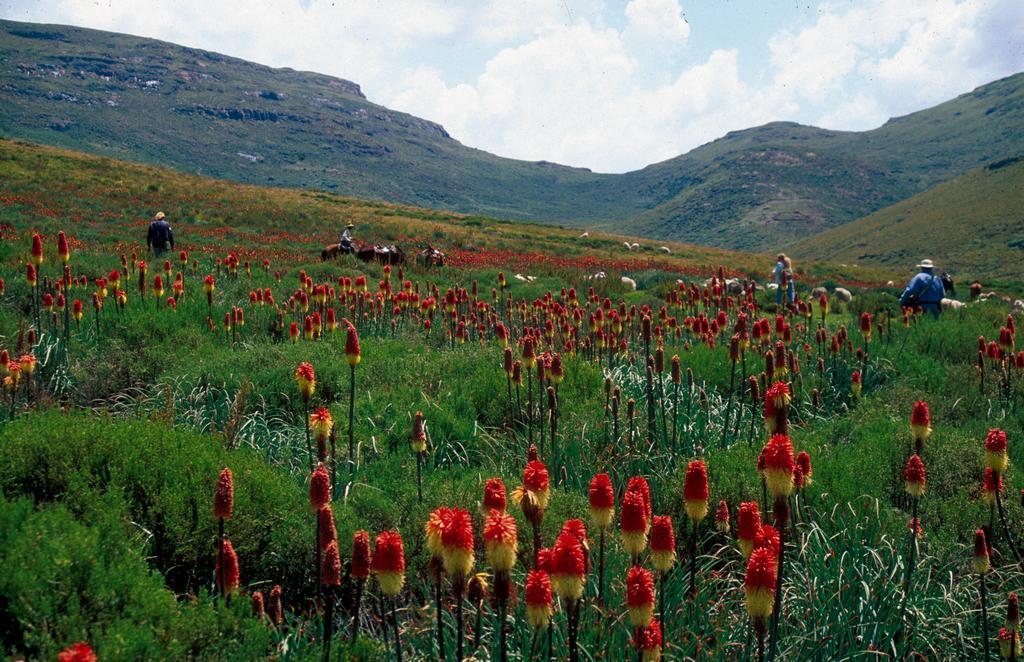Could you give a brief overview of what you see in this image? In the background we can see clouds in the sky, hills, people, plants and animals. 